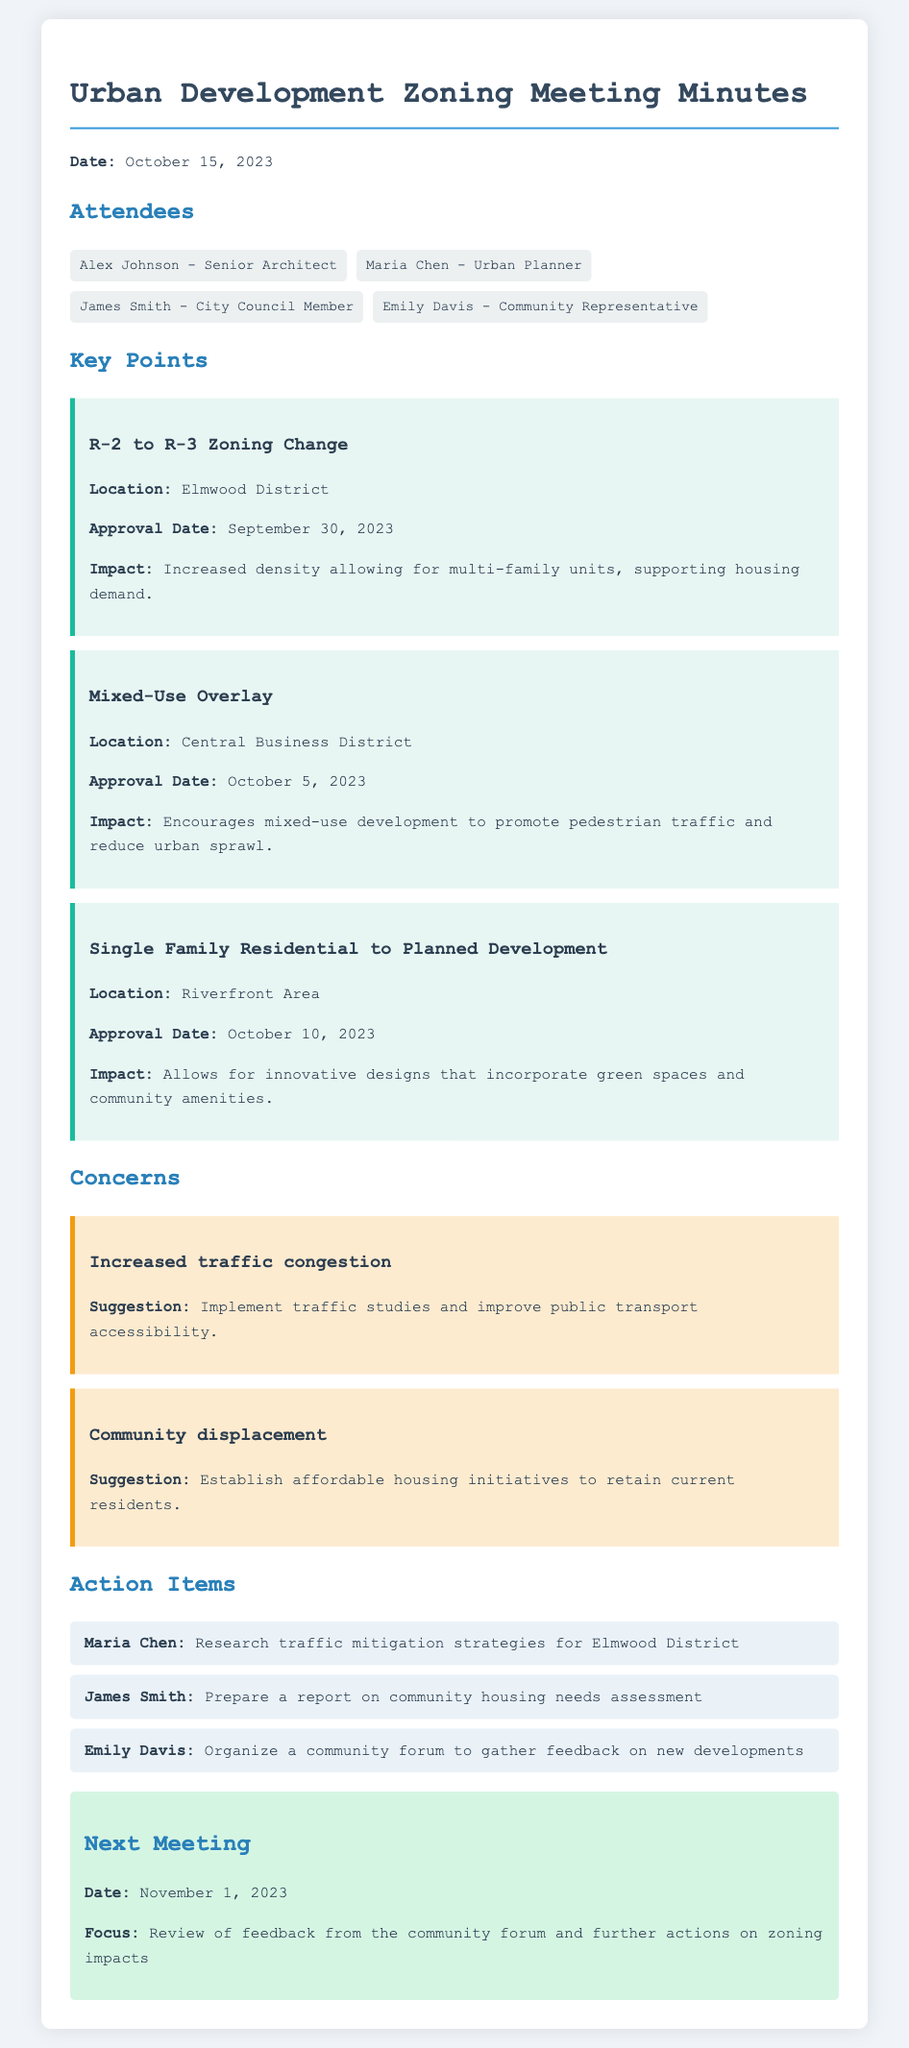What is the date of the meeting? The date of the meeting is explicitly stated at the beginning of the document.
Answer: October 15, 2023 Who is the Senior Architect present at the meeting? The document lists the attendees, including their titles and names.
Answer: Alex Johnson What change was approved in the Elmwood District? The details about zoning changes are outlined in the key points section of the document.
Answer: R-2 to R-3 Zoning Change What is one concern raised about the new zoning approvals? The document highlights specific concerns in a separate section.
Answer: Increased traffic congestion Who is responsible for researching traffic mitigation strategies? The action items specify who will take on each task after discussion.
Answer: Maria Chen What will the next meeting focus on? The next meeting section outlines its purpose.
Answer: Review of feedback from the community forum and further actions on zoning impacts On what date was the Mixed-Use Overlay approved? The approval dates for each zoning change are detailed in the key point section.
Answer: October 5, 2023 What is one suggestion to address community displacement? Suggestions related to concerns are provided in their respective sections.
Answer: Establish affordable housing initiatives How many attendees were present at the meeting? The number of attendees can be discerned from the list provided in the document.
Answer: Four 